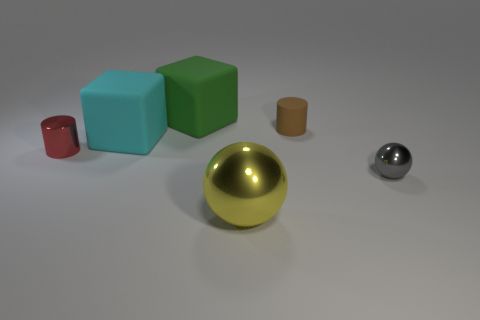Add 2 red things. How many objects exist? 8 Subtract all cylinders. How many objects are left? 4 Add 1 small spheres. How many small spheres are left? 2 Add 3 purple metal cylinders. How many purple metal cylinders exist? 3 Subtract 0 purple balls. How many objects are left? 6 Subtract all metallic objects. Subtract all large brown shiny balls. How many objects are left? 3 